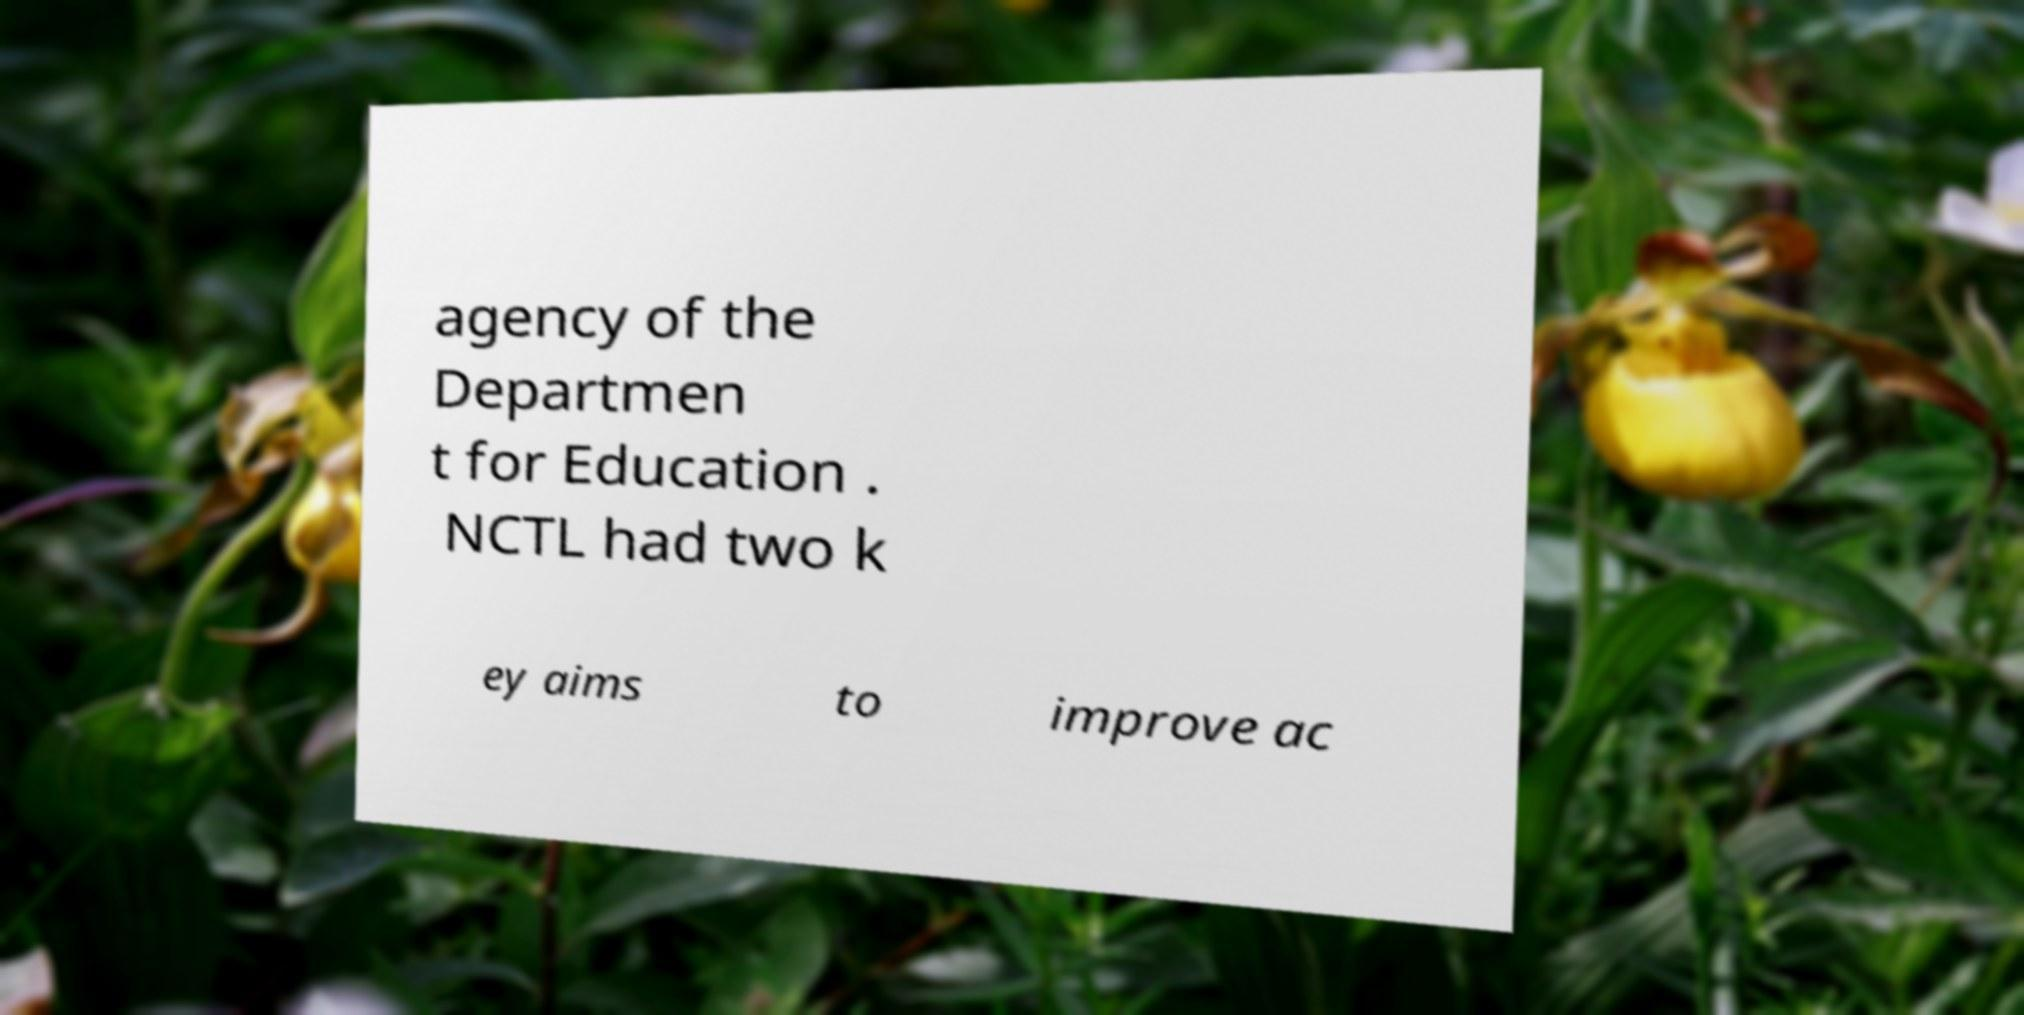I need the written content from this picture converted into text. Can you do that? agency of the Departmen t for Education . NCTL had two k ey aims to improve ac 